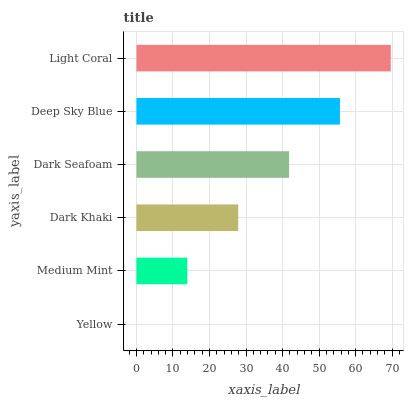Is Yellow the minimum?
Answer yes or no. Yes. Is Light Coral the maximum?
Answer yes or no. Yes. Is Medium Mint the minimum?
Answer yes or no. No. Is Medium Mint the maximum?
Answer yes or no. No. Is Medium Mint greater than Yellow?
Answer yes or no. Yes. Is Yellow less than Medium Mint?
Answer yes or no. Yes. Is Yellow greater than Medium Mint?
Answer yes or no. No. Is Medium Mint less than Yellow?
Answer yes or no. No. Is Dark Seafoam the high median?
Answer yes or no. Yes. Is Dark Khaki the low median?
Answer yes or no. Yes. Is Light Coral the high median?
Answer yes or no. No. Is Medium Mint the low median?
Answer yes or no. No. 